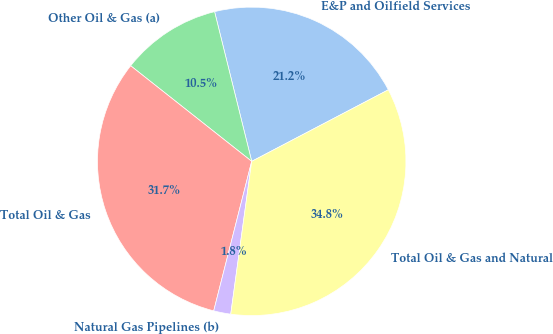Convert chart to OTSL. <chart><loc_0><loc_0><loc_500><loc_500><pie_chart><fcel>E&P and Oilfield Services<fcel>Other Oil & Gas (a)<fcel>Total Oil & Gas<fcel>Natural Gas Pipelines (b)<fcel>Total Oil & Gas and Natural<nl><fcel>21.19%<fcel>10.49%<fcel>31.68%<fcel>1.79%<fcel>34.85%<nl></chart> 